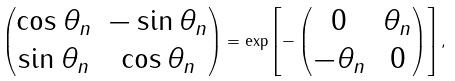Convert formula to latex. <formula><loc_0><loc_0><loc_500><loc_500>\begin{pmatrix} \cos \theta _ { n } & - \sin \theta _ { n } \\ \sin \theta _ { n } & \cos \theta _ { n } \\ \end{pmatrix} = \exp \left [ - \begin{pmatrix} 0 & \theta _ { n } \\ - \theta _ { n } & 0 \end{pmatrix} \right ] ,</formula> 